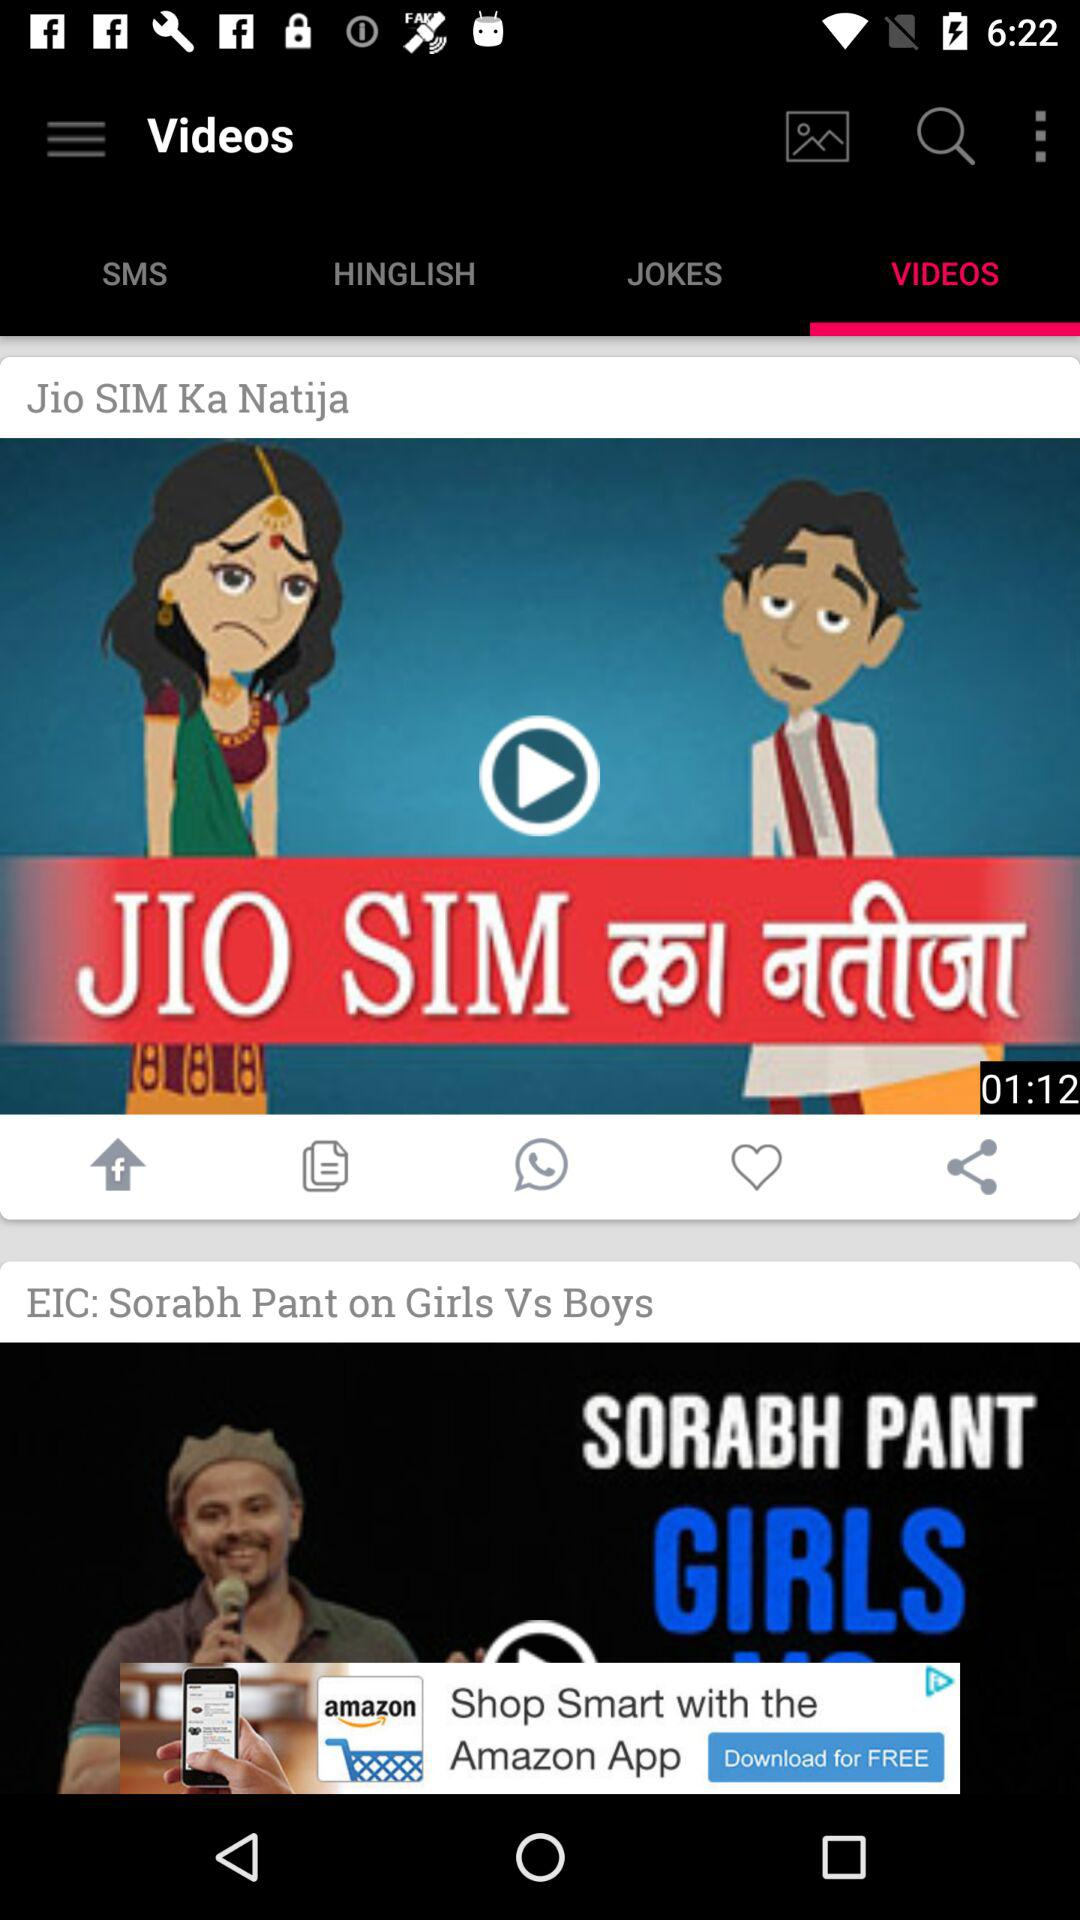Which tab is selected? The selected tab is "VIDEOS". 